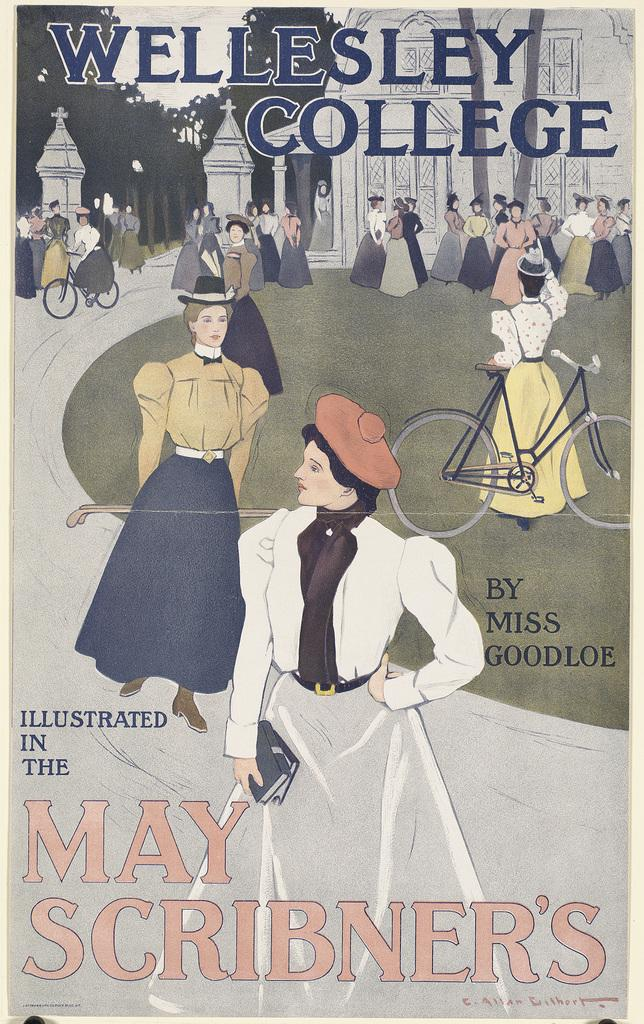Provide a one-sentence caption for the provided image. A poster (or magazine cover) shows a stylized scene from Wellesley College. 